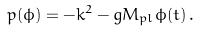<formula> <loc_0><loc_0><loc_500><loc_500>p ( \phi ) = - k ^ { 2 } - g M _ { p l } \phi ( t ) \, .</formula> 